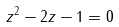Convert formula to latex. <formula><loc_0><loc_0><loc_500><loc_500>z ^ { 2 } - 2 z - 1 = 0</formula> 